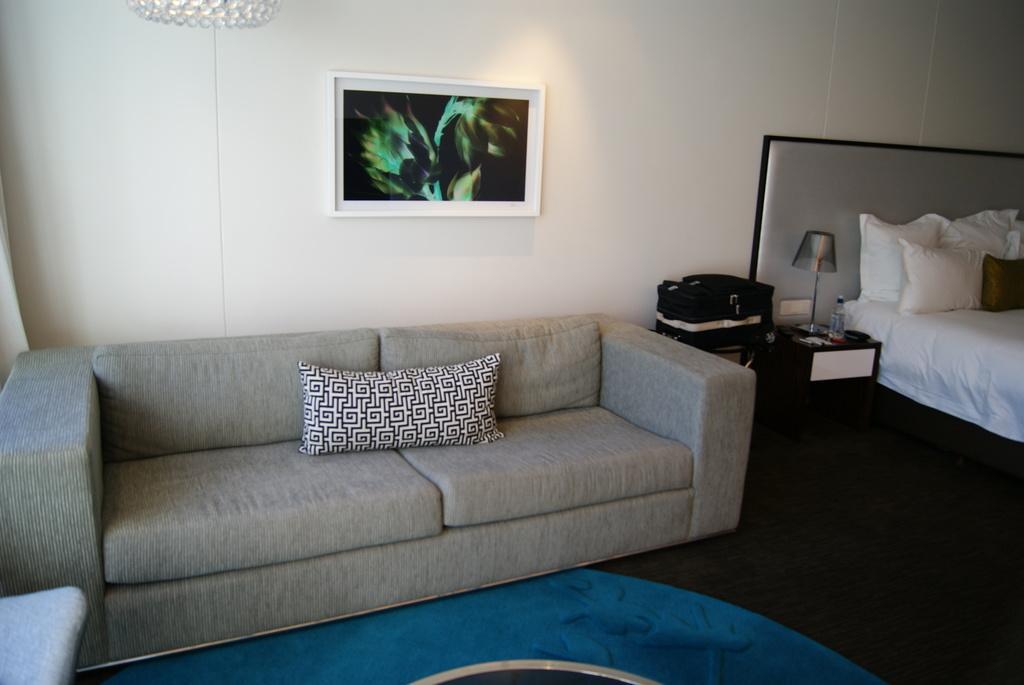Could you give a brief overview of what you see in this image? Here we can see a sofa set on the floor, and at side here is the cot and pillows on it, and at back here is the wall and photo frame on it. 